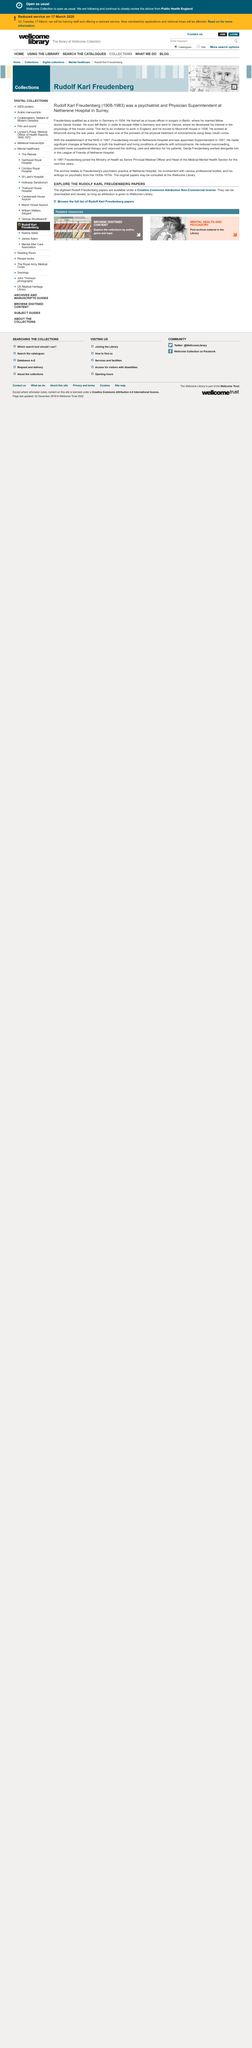Outline some significant characteristics in this image. Rudolf Karl Freudenberg was born in 1908. The late psychiatrist and Physician Superintendent at Netherene Hospital in Surrey, who married Gerda Vorster, was a physician who provided medical care and supervision to patients at the hospital. In 1934, Freudenberg qualified as a doctor. 